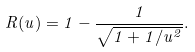<formula> <loc_0><loc_0><loc_500><loc_500>R ( u ) = 1 - \frac { 1 } { \sqrt { 1 + 1 / u ^ { 2 } } } .</formula> 